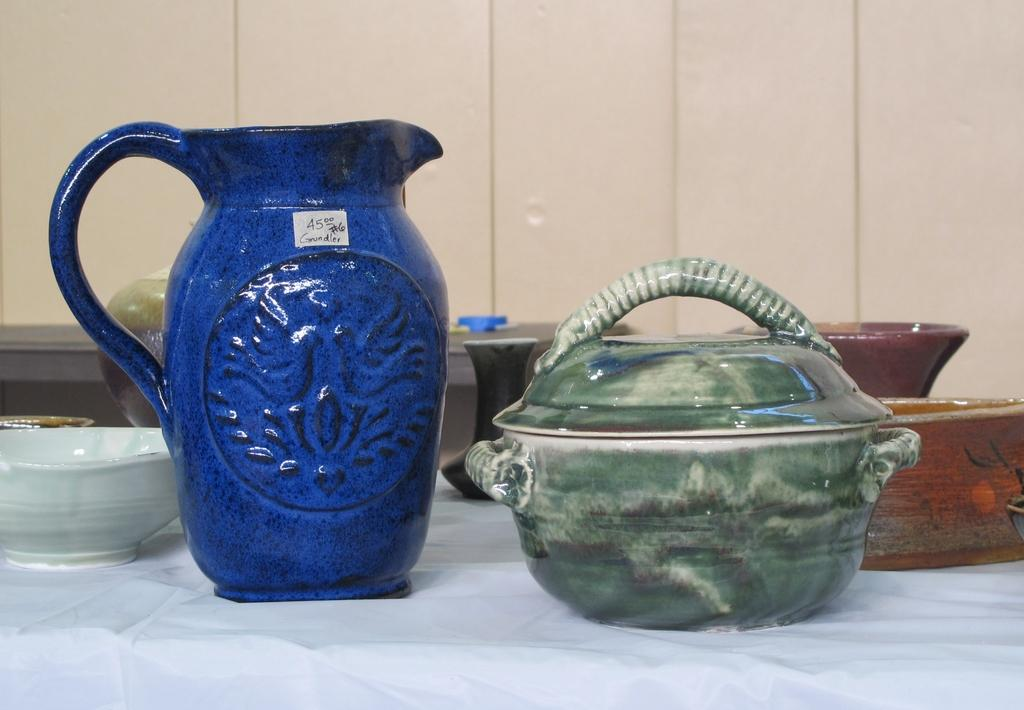What objects are in the foreground of the image? There are pots and bowls in the foreground of the image. Where are the pots and bowls located? The pots and bowls are on a table. What can be seen in the background of the image? There is another table and a wall in the background of the image. What country are the women from in the image? There are no women present in the image, so it is not possible to determine their country of origin. 